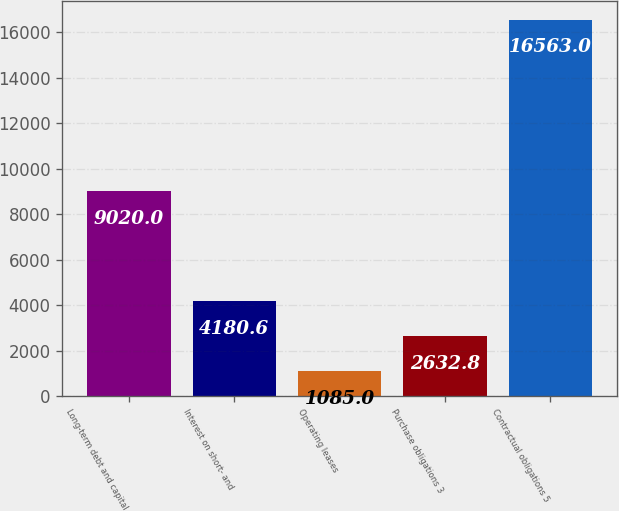Convert chart. <chart><loc_0><loc_0><loc_500><loc_500><bar_chart><fcel>Long-term debt and capital<fcel>Interest on short- and<fcel>Operating leases<fcel>Purchase obligations 3<fcel>Contractual obligations 5<nl><fcel>9020<fcel>4180.6<fcel>1085<fcel>2632.8<fcel>16563<nl></chart> 